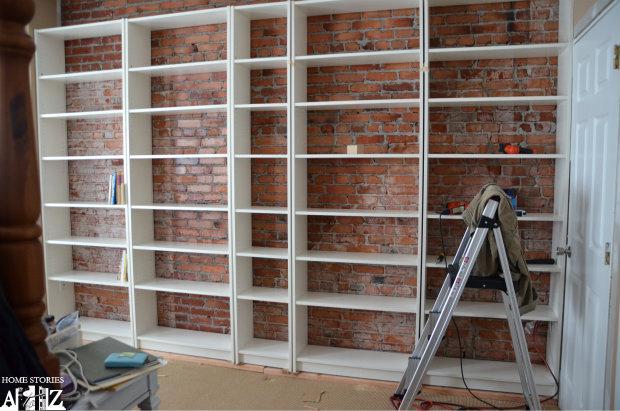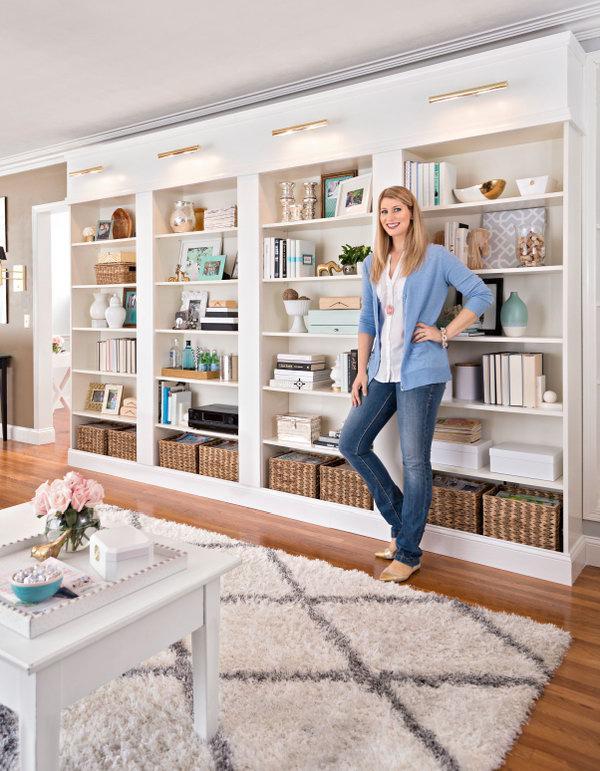The first image is the image on the left, the second image is the image on the right. Assess this claim about the two images: "Each image includes an empty white storage unit that reaches toward the ceiling, and at least one image shows a storage unit on a light wood floor.". Correct or not? Answer yes or no. No. The first image is the image on the left, the second image is the image on the right. Analyze the images presented: Is the assertion "The shelving unit in the image on the right is empty." valid? Answer yes or no. No. 